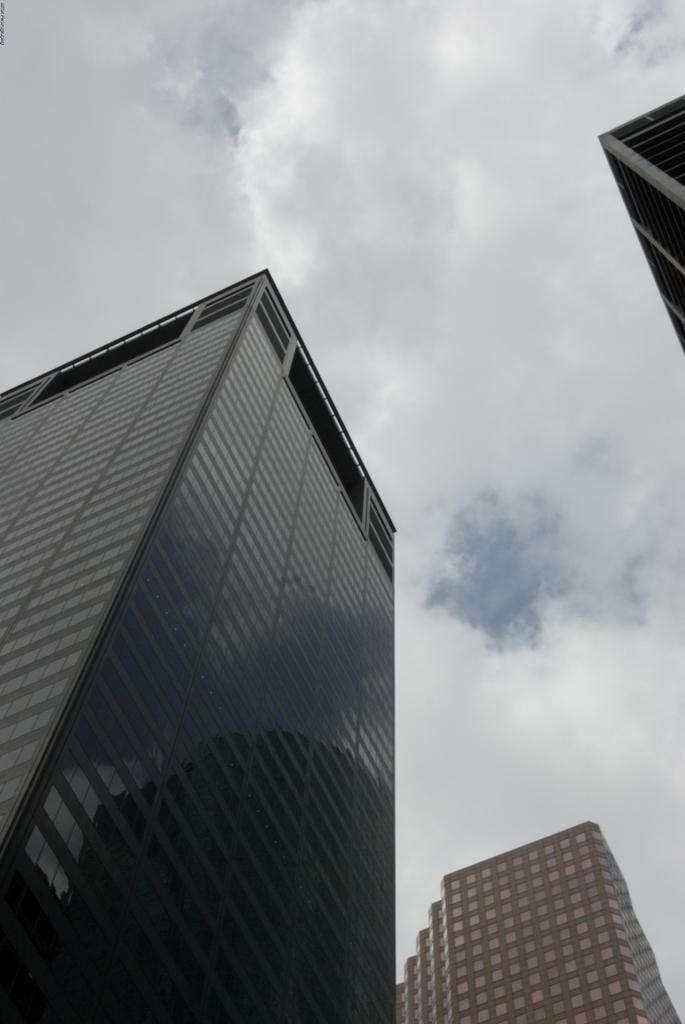In one or two sentences, can you explain what this image depicts? In this picture I can see there are a few buildings and they have glass windows and the sky is cloudy. 